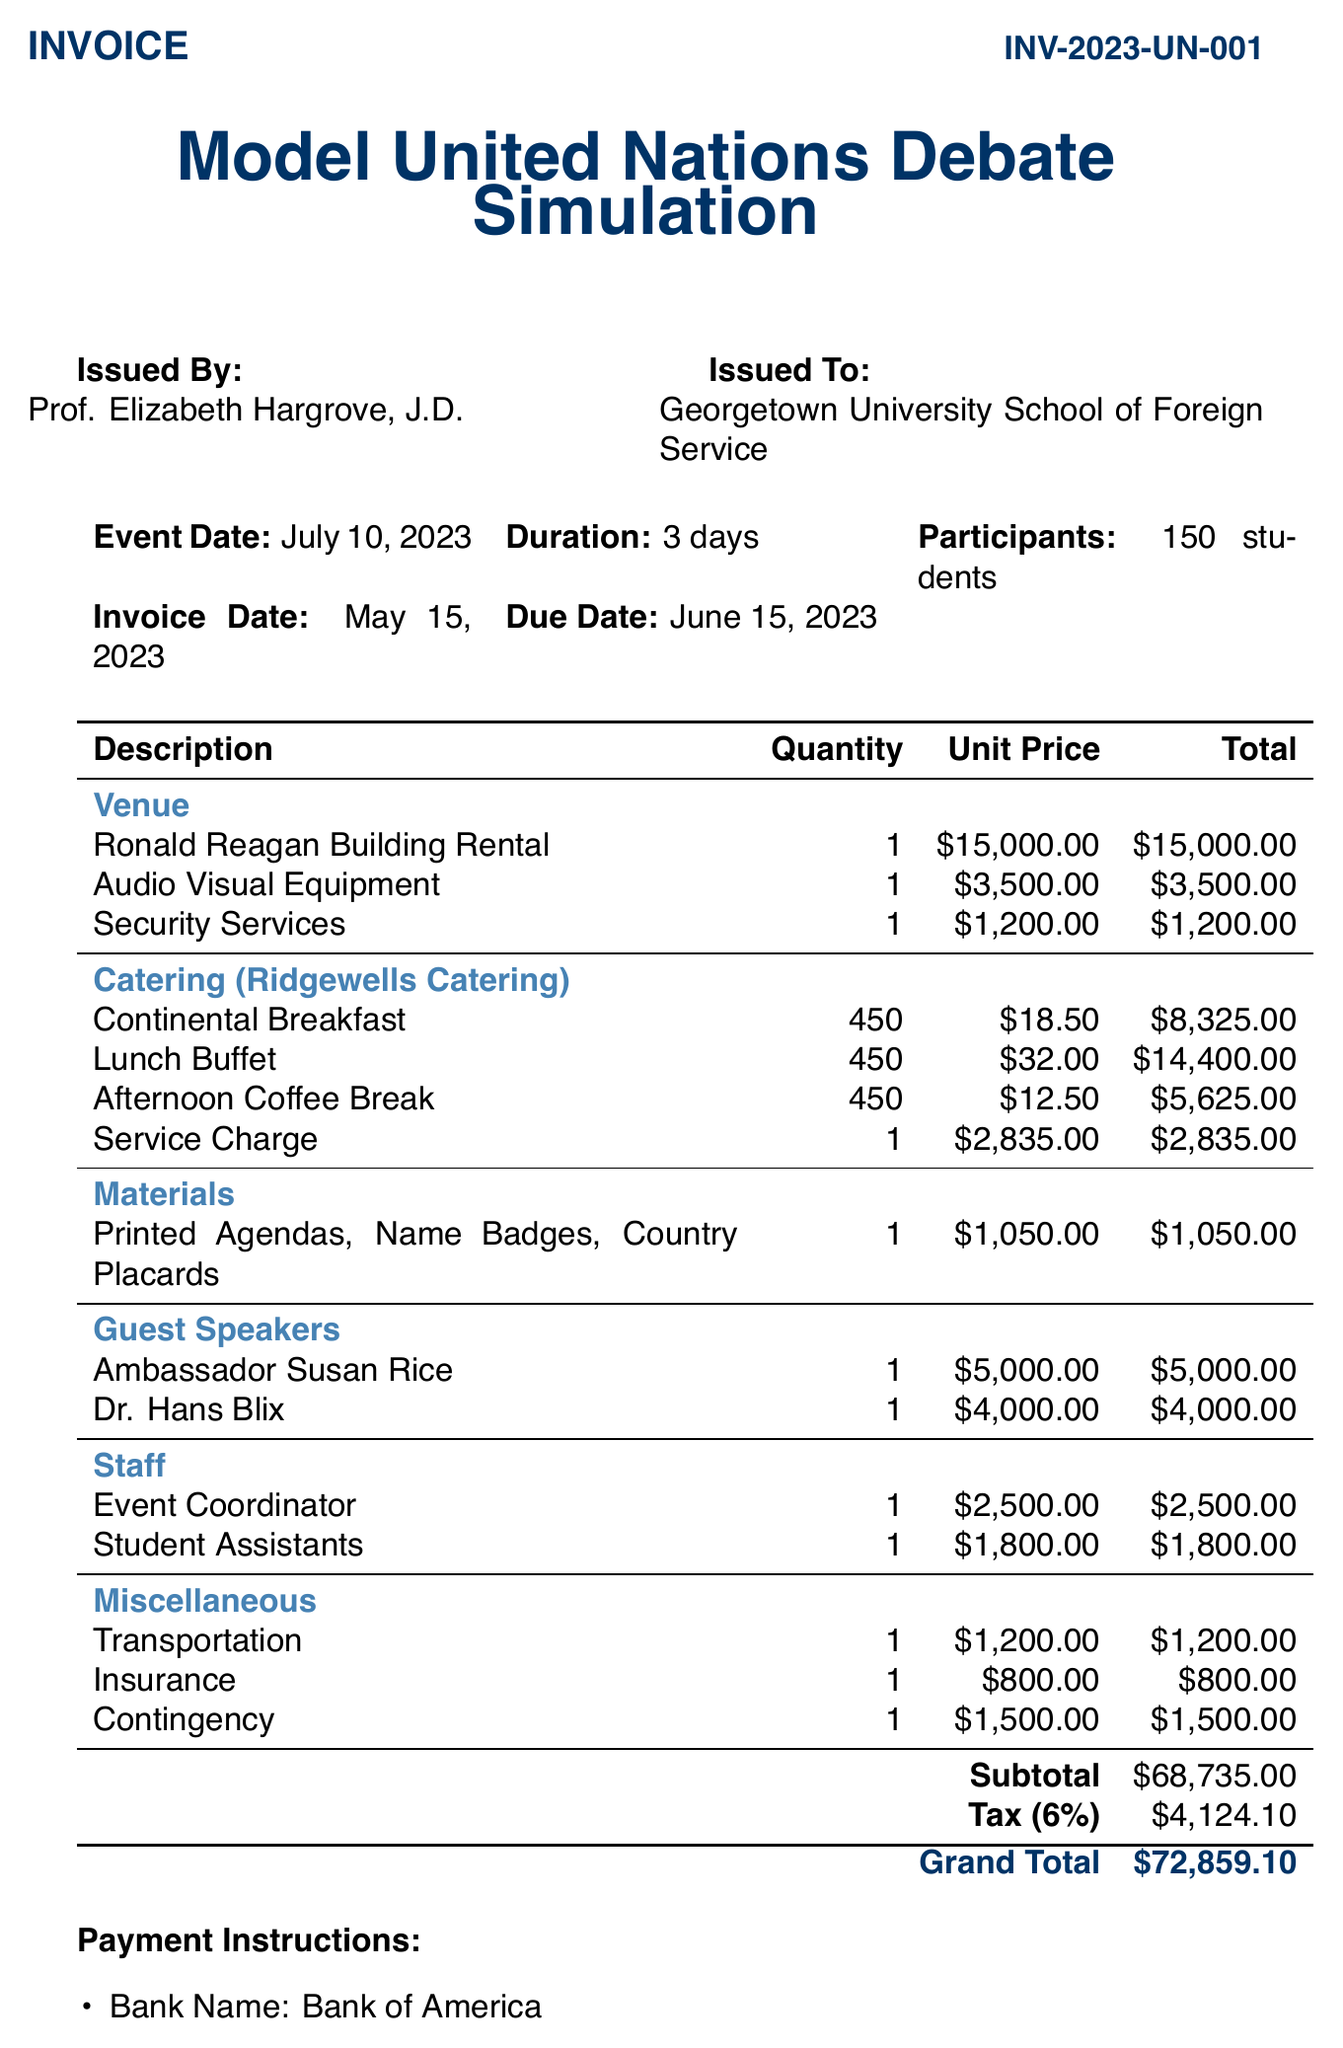What is the invoice number? The invoice number is provided in the document as a unique identifier for this transaction.
Answer: INV-2023-UN-001 What is the total catering cost? The total catering cost is given as the sum of all catering items and service charges.
Answer: $31,185 Who is the event coordinator? The name of the event coordinator is mentioned in the document along with their role and associated compensation.
Answer: Event Coordinator What is the rental fee for the venue? The document specifies the rental fee explicitly for the venue used during the event.
Answer: $15,000 How many days is the event scheduled to last? The duration of the event is clearly stated in the event details section of the invoice.
Answer: 3 days What is the grand total amount due? The grand total is listed at the bottom of the invoice and includes all charges and taxes.
Answer: $72,859.10 What is the name of the catering provider? The catering provider's name is specified in the catering section of the invoice for clarity.
Answer: Ridgewells Catering What amount is allocated for guest speaker honorariums? The total amount for guest speaker honorariums combines the fees for both speakers mentioned.
Answer: $9,000 What is the payment due date? The due date is provided in the invoice details for reference on payment timing.
Answer: June 15, 2023 